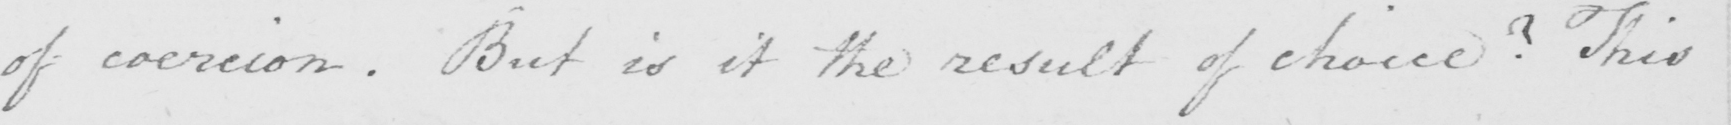What text is written in this handwritten line? of coercion . But is it the result of choice ?  This 